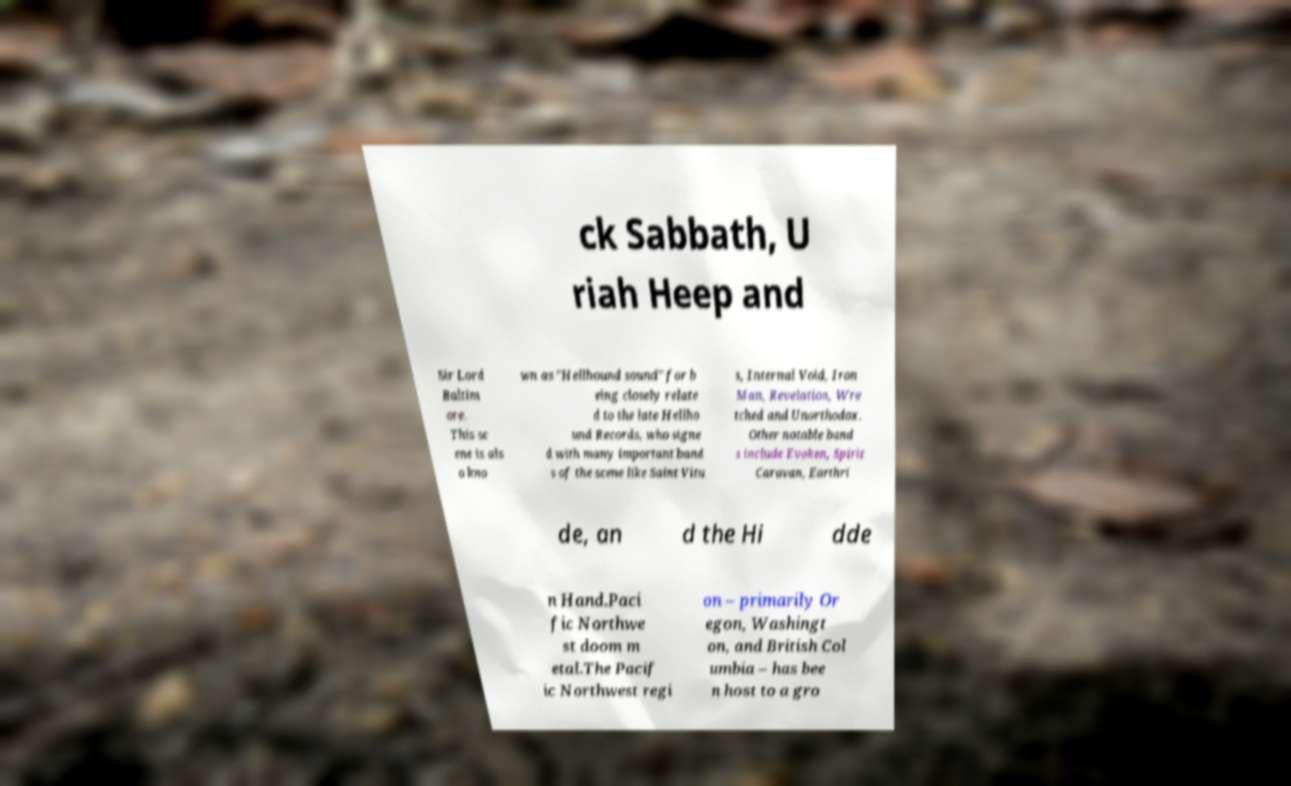Can you accurately transcribe the text from the provided image for me? ck Sabbath, U riah Heep and Sir Lord Baltim ore. This sc ene is als o kno wn as "Hellhound sound" for b eing closely relate d to the late Hellho und Records, who signe d with many important band s of the scene like Saint Vitu s, Internal Void, Iron Man, Revelation, Wre tched and Unorthodox. Other notable band s include Evoken, Spirit Caravan, Earthri de, an d the Hi dde n Hand.Paci fic Northwe st doom m etal.The Pacif ic Northwest regi on – primarily Or egon, Washingt on, and British Col umbia – has bee n host to a gro 